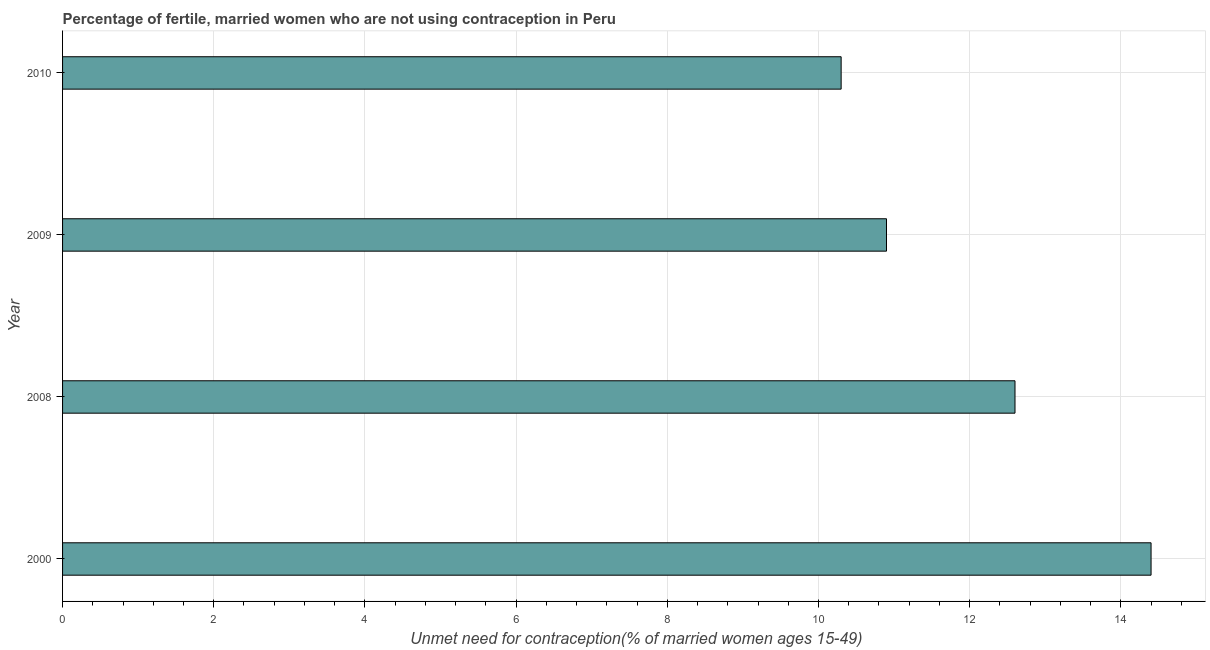Does the graph contain grids?
Your answer should be very brief. Yes. What is the title of the graph?
Provide a succinct answer. Percentage of fertile, married women who are not using contraception in Peru. What is the label or title of the X-axis?
Your answer should be very brief.  Unmet need for contraception(% of married women ages 15-49). Across all years, what is the maximum number of married women who are not using contraception?
Offer a terse response. 14.4. In which year was the number of married women who are not using contraception maximum?
Keep it short and to the point. 2000. In which year was the number of married women who are not using contraception minimum?
Provide a short and direct response. 2010. What is the sum of the number of married women who are not using contraception?
Provide a short and direct response. 48.2. What is the difference between the number of married women who are not using contraception in 2008 and 2009?
Ensure brevity in your answer.  1.7. What is the average number of married women who are not using contraception per year?
Your response must be concise. 12.05. What is the median number of married women who are not using contraception?
Offer a very short reply. 11.75. Do a majority of the years between 2000 and 2010 (inclusive) have number of married women who are not using contraception greater than 0.4 %?
Offer a terse response. Yes. What is the ratio of the number of married women who are not using contraception in 2000 to that in 2010?
Your response must be concise. 1.4. Is the number of married women who are not using contraception in 2000 less than that in 2009?
Give a very brief answer. No. Is the difference between the number of married women who are not using contraception in 2000 and 2008 greater than the difference between any two years?
Offer a very short reply. No. What is the difference between the highest and the second highest number of married women who are not using contraception?
Your response must be concise. 1.8. In how many years, is the number of married women who are not using contraception greater than the average number of married women who are not using contraception taken over all years?
Provide a succinct answer. 2. How many bars are there?
Offer a terse response. 4. How many years are there in the graph?
Your answer should be compact. 4. Are the values on the major ticks of X-axis written in scientific E-notation?
Provide a succinct answer. No. What is the  Unmet need for contraception(% of married women ages 15-49) of 2010?
Your answer should be compact. 10.3. What is the difference between the  Unmet need for contraception(% of married women ages 15-49) in 2000 and 2008?
Your answer should be very brief. 1.8. What is the difference between the  Unmet need for contraception(% of married women ages 15-49) in 2000 and 2009?
Give a very brief answer. 3.5. What is the difference between the  Unmet need for contraception(% of married women ages 15-49) in 2008 and 2009?
Offer a terse response. 1.7. What is the ratio of the  Unmet need for contraception(% of married women ages 15-49) in 2000 to that in 2008?
Keep it short and to the point. 1.14. What is the ratio of the  Unmet need for contraception(% of married women ages 15-49) in 2000 to that in 2009?
Offer a terse response. 1.32. What is the ratio of the  Unmet need for contraception(% of married women ages 15-49) in 2000 to that in 2010?
Your response must be concise. 1.4. What is the ratio of the  Unmet need for contraception(% of married women ages 15-49) in 2008 to that in 2009?
Ensure brevity in your answer.  1.16. What is the ratio of the  Unmet need for contraception(% of married women ages 15-49) in 2008 to that in 2010?
Offer a very short reply. 1.22. What is the ratio of the  Unmet need for contraception(% of married women ages 15-49) in 2009 to that in 2010?
Give a very brief answer. 1.06. 